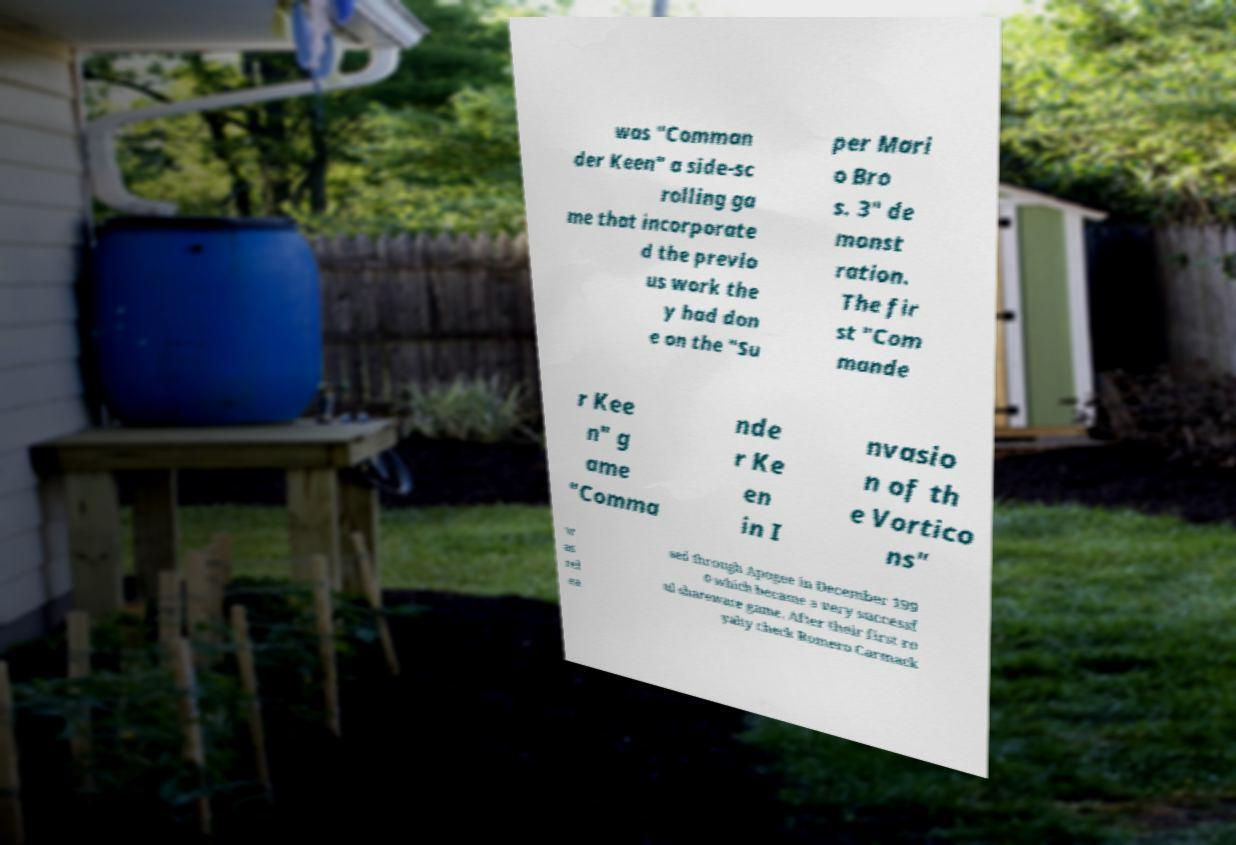I need the written content from this picture converted into text. Can you do that? was "Comman der Keen" a side-sc rolling ga me that incorporate d the previo us work the y had don e on the "Su per Mari o Bro s. 3" de monst ration. The fir st "Com mande r Kee n" g ame "Comma nde r Ke en in I nvasio n of th e Vortico ns" w as rel ea sed through Apogee in December 199 0 which became a very successf ul shareware game. After their first ro yalty check Romero Carmack 